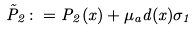<formula> <loc_0><loc_0><loc_500><loc_500>\tilde { P } _ { 2 } \colon = P _ { 2 } ( x ) + \mu _ { a } d ( x ) \sigma _ { 1 }</formula> 